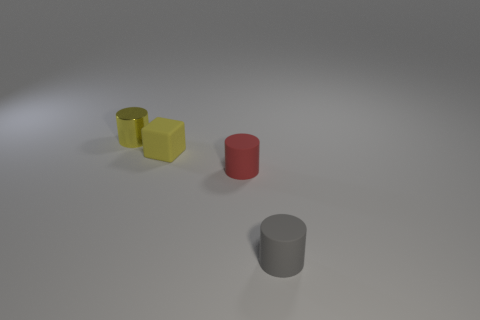Subtract all tiny yellow cylinders. How many cylinders are left? 2 Add 3 green balls. How many objects exist? 7 Subtract all red matte cylinders. Subtract all tiny yellow matte blocks. How many objects are left? 2 Add 4 tiny matte cylinders. How many tiny matte cylinders are left? 6 Add 4 large spheres. How many large spheres exist? 4 Subtract all red cylinders. How many cylinders are left? 2 Subtract 1 yellow cubes. How many objects are left? 3 Subtract all blocks. How many objects are left? 3 Subtract all purple cubes. Subtract all yellow balls. How many cubes are left? 1 Subtract all red balls. How many gray cylinders are left? 1 